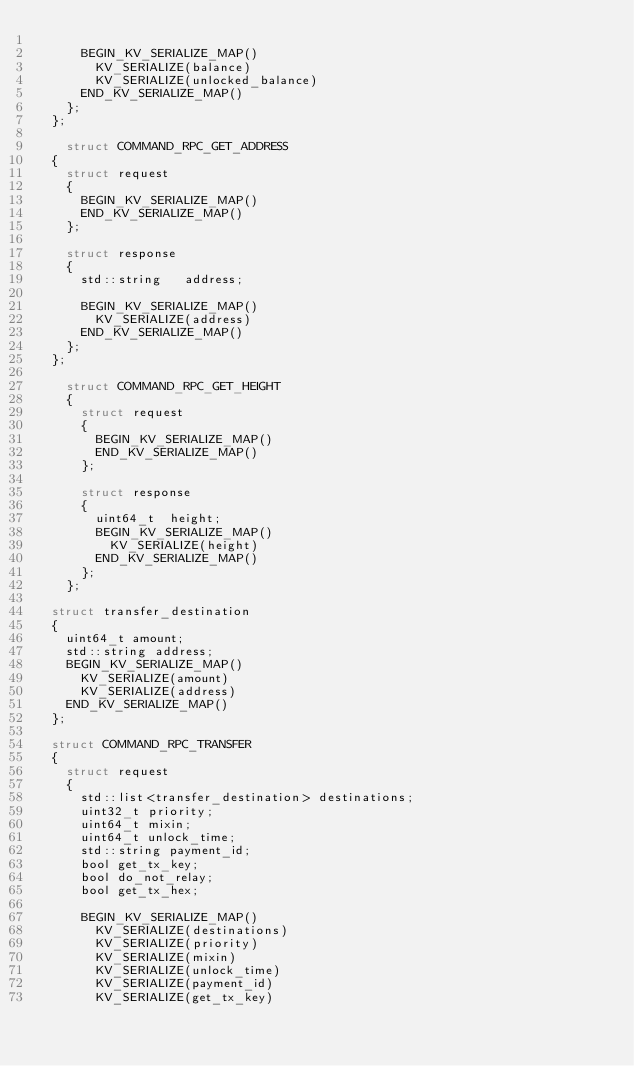<code> <loc_0><loc_0><loc_500><loc_500><_C_>
      BEGIN_KV_SERIALIZE_MAP()
        KV_SERIALIZE(balance)
        KV_SERIALIZE(unlocked_balance)
      END_KV_SERIALIZE_MAP()
    };
  };

    struct COMMAND_RPC_GET_ADDRESS
  {
    struct request
    {
      BEGIN_KV_SERIALIZE_MAP()
      END_KV_SERIALIZE_MAP()
    };

    struct response
    {
      std::string   address;

      BEGIN_KV_SERIALIZE_MAP()
        KV_SERIALIZE(address)
      END_KV_SERIALIZE_MAP()
    };
  };

    struct COMMAND_RPC_GET_HEIGHT
    {
      struct request
      {
        BEGIN_KV_SERIALIZE_MAP()
        END_KV_SERIALIZE_MAP()
      };

      struct response
      {
        uint64_t  height;
        BEGIN_KV_SERIALIZE_MAP()
          KV_SERIALIZE(height)
        END_KV_SERIALIZE_MAP()
      };
    };

  struct transfer_destination
  {
    uint64_t amount;
    std::string address;
    BEGIN_KV_SERIALIZE_MAP()
      KV_SERIALIZE(amount)
      KV_SERIALIZE(address)
    END_KV_SERIALIZE_MAP()
  };

  struct COMMAND_RPC_TRANSFER
  {
    struct request
    {
      std::list<transfer_destination> destinations;
      uint32_t priority;
      uint64_t mixin;
      uint64_t unlock_time;
      std::string payment_id;
      bool get_tx_key;
      bool do_not_relay;
      bool get_tx_hex;

      BEGIN_KV_SERIALIZE_MAP()
        KV_SERIALIZE(destinations)
        KV_SERIALIZE(priority)
        KV_SERIALIZE(mixin)
        KV_SERIALIZE(unlock_time)
        KV_SERIALIZE(payment_id)
        KV_SERIALIZE(get_tx_key)</code> 